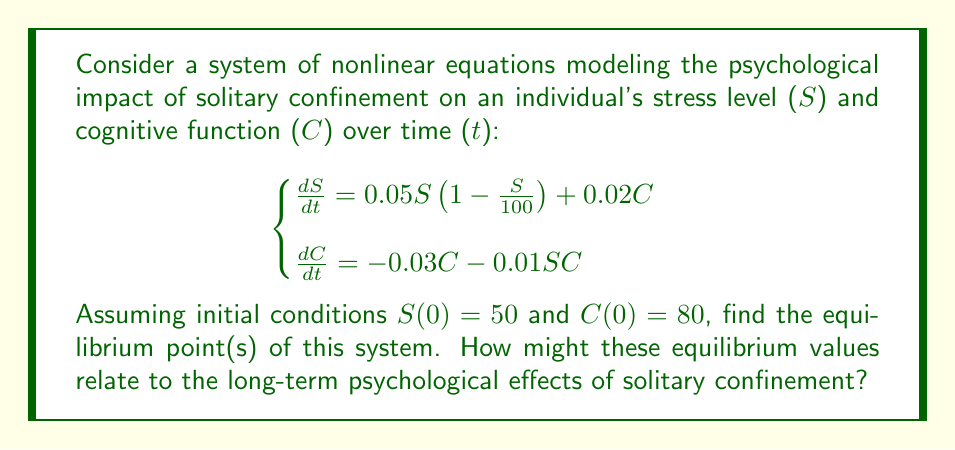Give your solution to this math problem. To find the equilibrium point(s), we set both equations equal to zero and solve for $S$ and $C$:

1) Set $\frac{dS}{dt} = 0$ and $\frac{dC}{dt} = 0$:

   $$\begin{cases}
   0 = 0.05S(1-\frac{S}{100}) + 0.02C \\
   0 = -0.03C - 0.01SC
   \end{cases}$$

2) From the second equation:
   $0 = -0.03C - 0.01SC$
   $C(0.03 + 0.01S) = 0$
   
   This gives us two possibilities: $C = 0$ or $S = -3$

3) Case 1: If $C = 0$, substitute into the first equation:
   $0 = 0.05S(1-\frac{S}{100})$
   $S = 0$ or $S = 100$

4) Case 2: If $S = -3$, this is not physically meaningful in our context as stress cannot be negative.

5) Now, let's check the equilibrium points $(0,0)$ and $(100,0)$:

   For $(0,0)$:
   $$\begin{cases}
   0 = 0.05(0)(1-\frac{0}{100}) + 0.02(0) = 0 \\
   0 = -0.03(0) - 0.01(0)(0) = 0
   \end{cases}$$
   This checks out.

   For $(100,0)$:
   $$\begin{cases}
   0 = 0.05(100)(1-\frac{100}{100}) + 0.02(0) = 0 \\
   0 = -0.03(0) - 0.01(100)(0) = 0
   \end{cases}$$
   This also checks out.

Therefore, the equilibrium points are $(0,0)$ and $(100,0)$.

In the context of solitary confinement, these equilibrium points suggest two potential long-term outcomes:
1) $(0,0)$: Both stress and cognitive function reduce to zero, possibly indicating complete emotional and cognitive shutdown.
2) $(100,0)$: Stress reaches its maximum while cognitive function drops to zero, suggesting severe psychological distress and cognitive impairment.

Both outcomes highlight the potentially devastating effects of prolonged solitary confinement on an individual's mental health.
Answer: Equilibrium points: $(0,0)$ and $(100,0)$ 